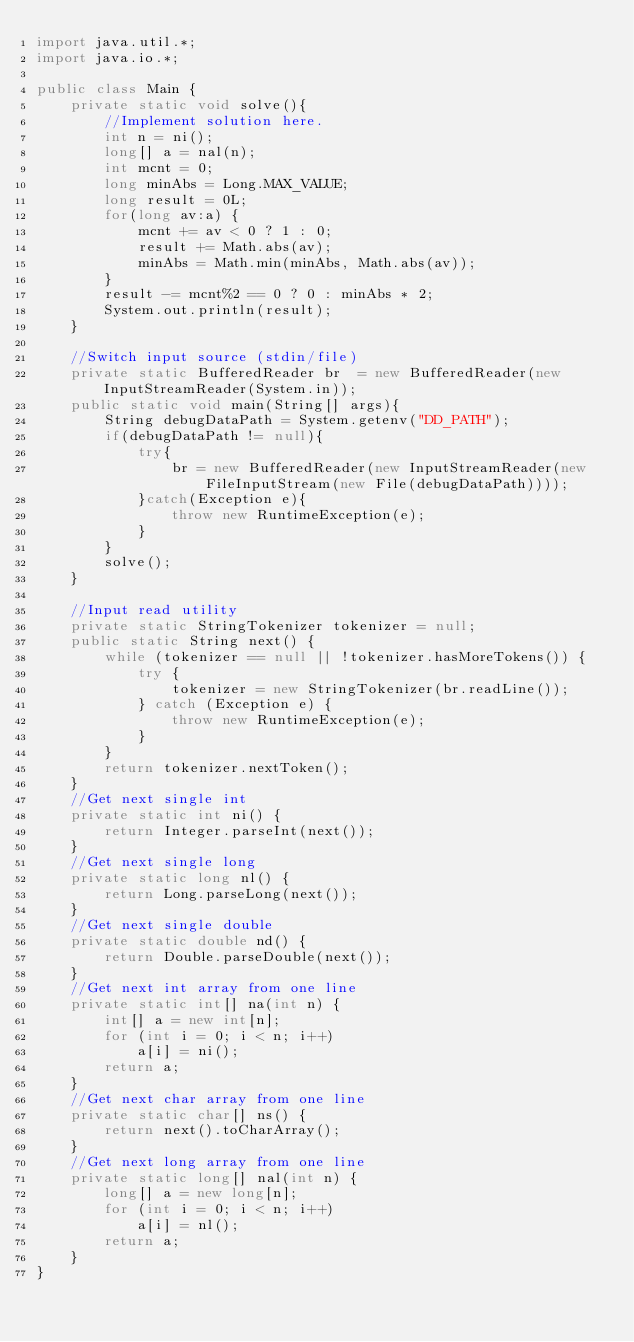Convert code to text. <code><loc_0><loc_0><loc_500><loc_500><_Java_>import java.util.*;
import java.io.*;

public class Main {
	private static void solve(){
		//Implement solution here.
		int n = ni();
		long[] a = nal(n);
		int mcnt = 0;
		long minAbs = Long.MAX_VALUE;
		long result = 0L;
		for(long av:a) {
			mcnt += av < 0 ? 1 : 0;
			result += Math.abs(av);
			minAbs = Math.min(minAbs, Math.abs(av));			
		}
		result -= mcnt%2 == 0 ? 0 : minAbs * 2;
		System.out.println(result);			
	}
	
	//Switch input source (stdin/file)
	private static BufferedReader br  = new BufferedReader(new InputStreamReader(System.in));
	public static void main(String[] args){
		String debugDataPath = System.getenv("DD_PATH");        
		if(debugDataPath != null){
			try{
				br = new BufferedReader(new InputStreamReader(new FileInputStream(new File(debugDataPath))));
			}catch(Exception e){
				throw new RuntimeException(e);
			}
		}
		solve();
	}

	//Input read utility
	private static StringTokenizer tokenizer = null;
	public static String next() {
		while (tokenizer == null || !tokenizer.hasMoreTokens()) {
			try {
				tokenizer = new StringTokenizer(br.readLine());
			} catch (Exception e) {
				throw new RuntimeException(e);
			}
		}
		return tokenizer.nextToken();
	}
	//Get next single int
	private static int ni() {
		return Integer.parseInt(next());
	}
	//Get next single long
	private static long nl() {
		return Long.parseLong(next());
	}
	//Get next single double
	private static double nd() {
		return Double.parseDouble(next());
	}
	//Get next int array from one line
	private static int[] na(int n) {
		int[] a = new int[n];
		for (int i = 0; i < n; i++)
			a[i] = ni();
		return a;
	}
	//Get next char array from one line
	private static char[] ns() {
		return next().toCharArray();
	}
	//Get next long array from one line
	private static long[] nal(int n) {
		long[] a = new long[n];
		for (int i = 0; i < n; i++)
			a[i] = nl();
		return a;
	}
}</code> 